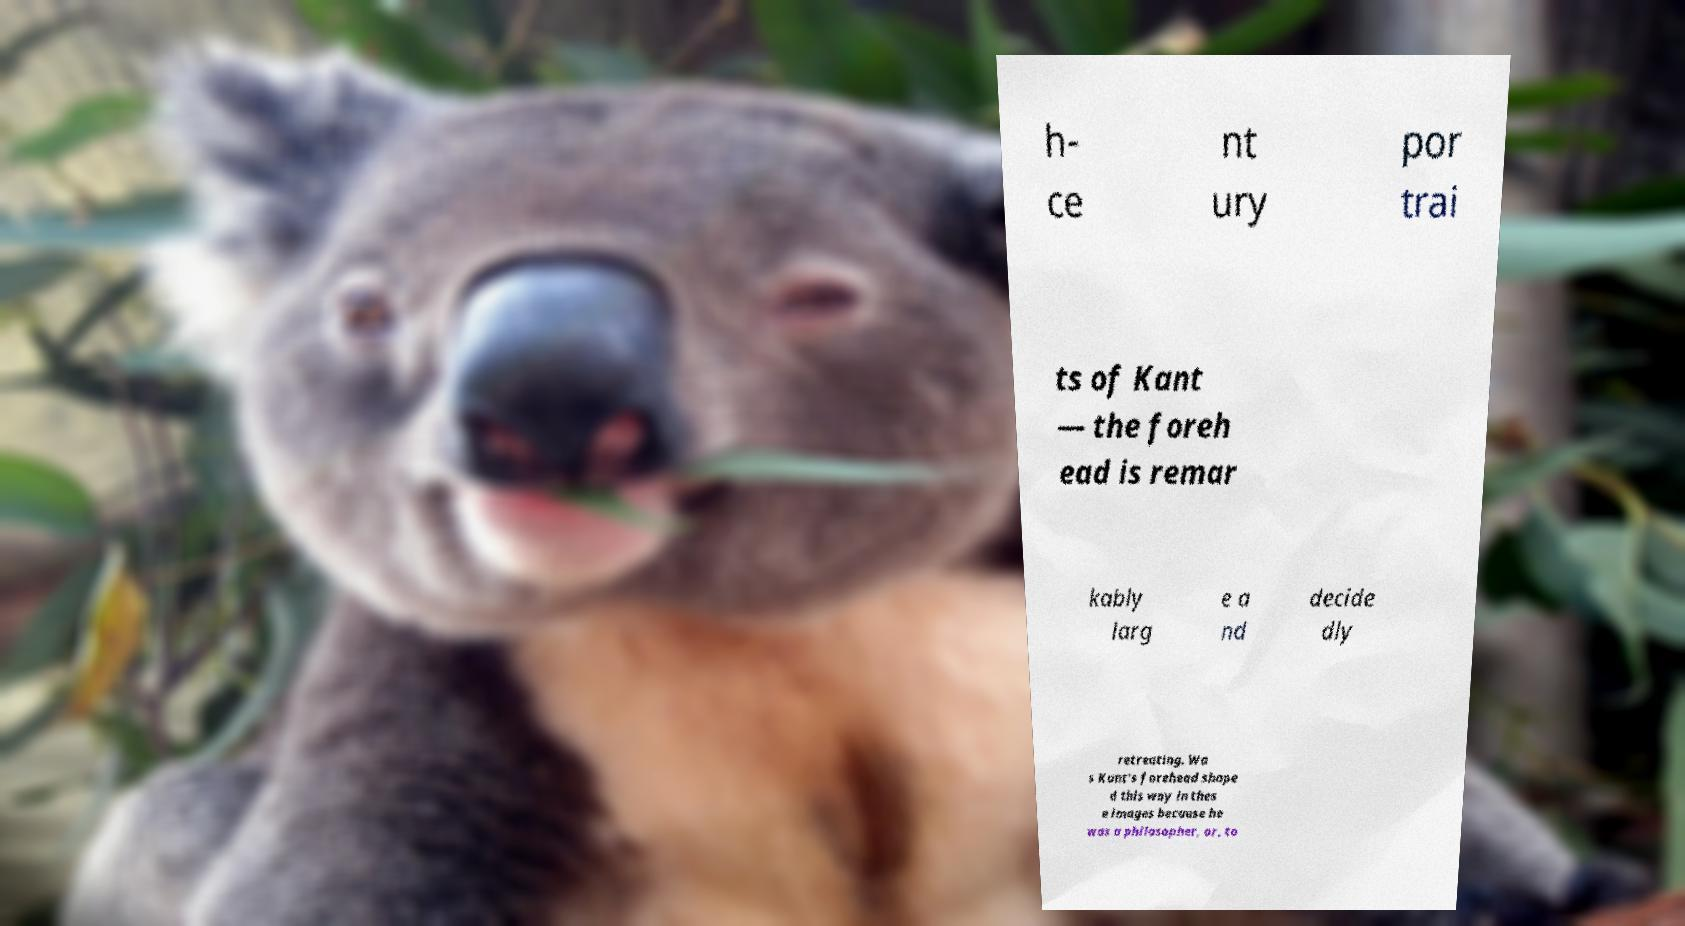Could you assist in decoding the text presented in this image and type it out clearly? h- ce nt ury por trai ts of Kant — the foreh ead is remar kably larg e a nd decide dly retreating. Wa s Kant's forehead shape d this way in thes e images because he was a philosopher, or, to 